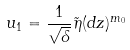<formula> <loc_0><loc_0><loc_500><loc_500>u _ { 1 } = \frac { 1 } { \sqrt { \delta } } \tilde { \eta } ( d z ) ^ { m _ { 0 } }</formula> 